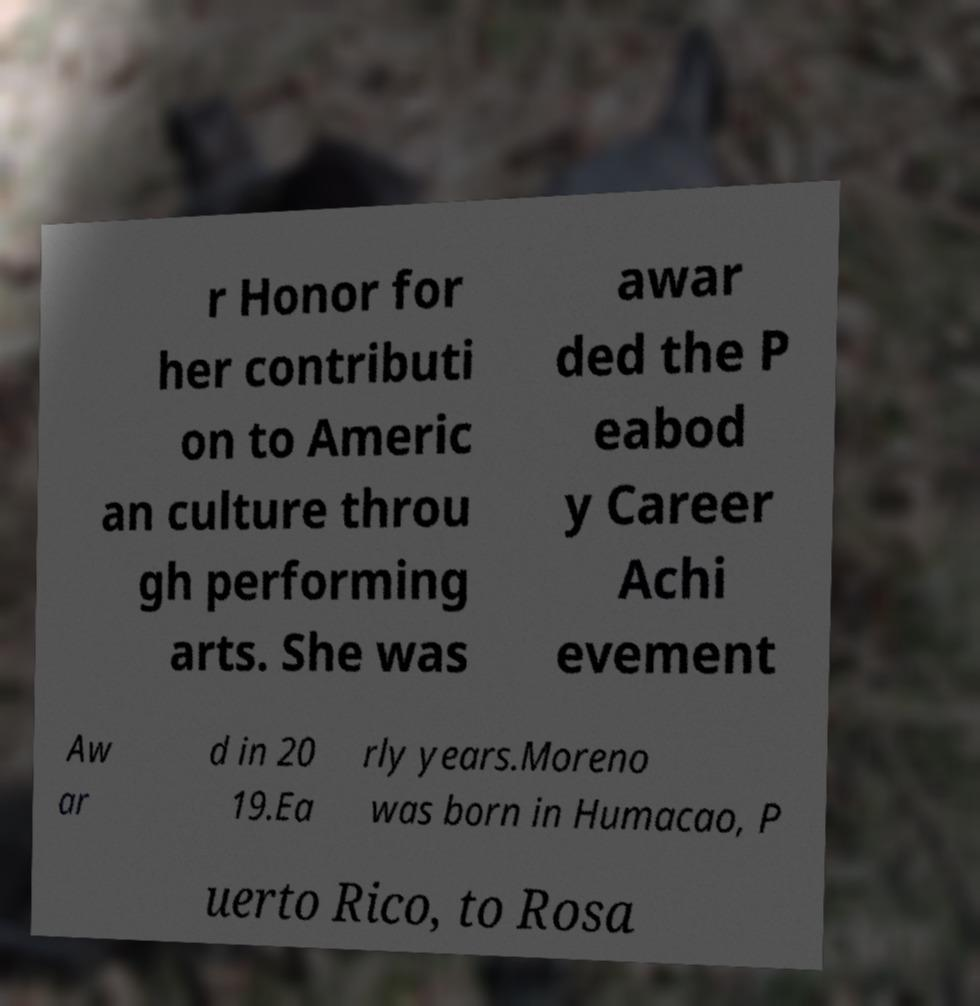Can you accurately transcribe the text from the provided image for me? r Honor for her contributi on to Americ an culture throu gh performing arts. She was awar ded the P eabod y Career Achi evement Aw ar d in 20 19.Ea rly years.Moreno was born in Humacao, P uerto Rico, to Rosa 